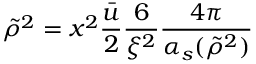Convert formula to latex. <formula><loc_0><loc_0><loc_500><loc_500>\tilde { \rho } ^ { 2 } = x ^ { 2 } \frac { \bar { u } } { 2 } \frac { 6 } { \xi ^ { 2 } } \frac { 4 \pi } { \alpha _ { s } ( \tilde { \rho } ^ { 2 } ) }</formula> 